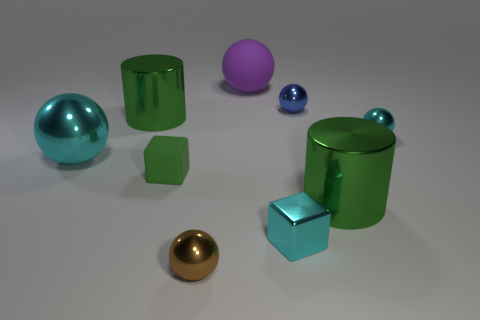There is a tiny sphere that is the same color as the large shiny ball; what is it made of?
Offer a terse response. Metal. Are there fewer tiny matte objects than big cyan rubber blocks?
Your response must be concise. No. Is there a large yellow cylinder that has the same material as the small green thing?
Your response must be concise. No. Is the shape of the brown shiny thing the same as the big metallic object in front of the small green object?
Give a very brief answer. No. There is a large cyan thing; are there any large rubber spheres in front of it?
Provide a short and direct response. No. What number of large cyan metallic things have the same shape as the purple matte thing?
Provide a short and direct response. 1. Does the large cyan ball have the same material as the tiny cube to the left of the purple object?
Offer a terse response. No. How many tiny brown spheres are there?
Provide a short and direct response. 1. There is a metal cylinder right of the matte sphere; what size is it?
Provide a succinct answer. Large. What number of brown balls are the same size as the green rubber thing?
Provide a short and direct response. 1. 